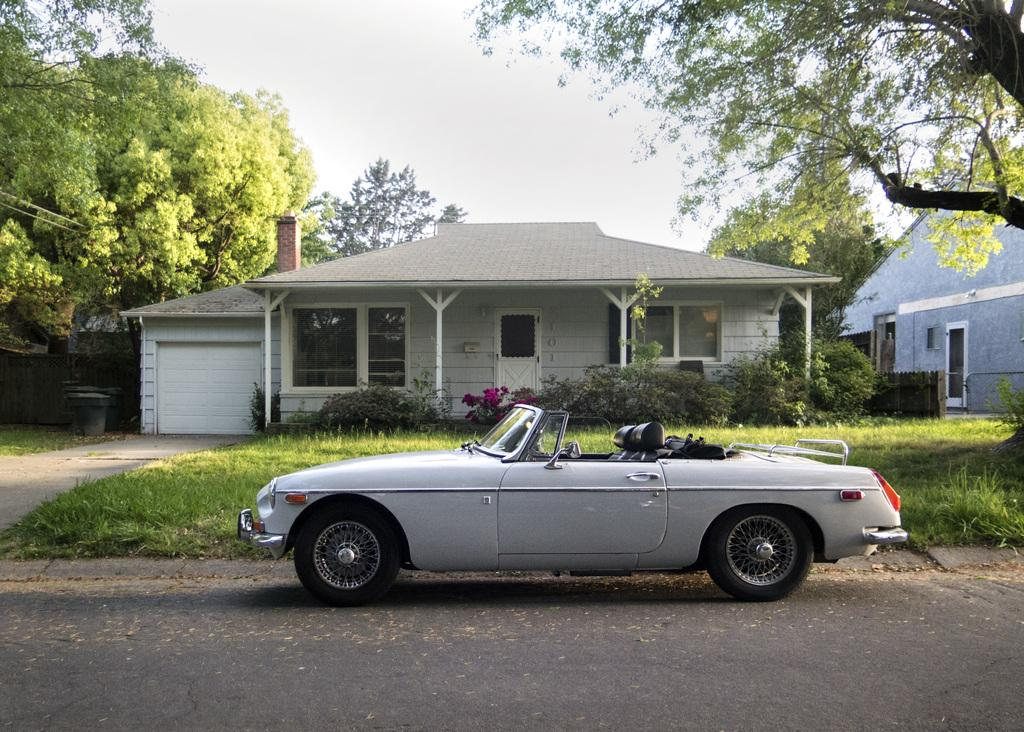What type of structures can be seen in the image? There are buildings in the image. What architectural features are present in the buildings? The image contains windows and doors. What type of vegetation is present in the image? Trees and plants are visible in the image. What mode of transportation can be seen in the image? There is a vehicle on the road in the image. What is the color of the sky in the image? The sky is white in color. Can you see a bomb exploding in the image? No, there is no bomb or explosion present in the image. Are there any fish visible in the image? No, there are no fish present in the image. 